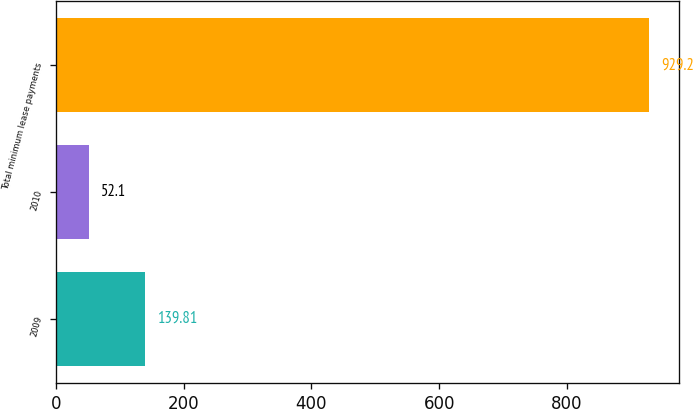Convert chart. <chart><loc_0><loc_0><loc_500><loc_500><bar_chart><fcel>2009<fcel>2010<fcel>Total minimum lease payments<nl><fcel>139.81<fcel>52.1<fcel>929.2<nl></chart> 